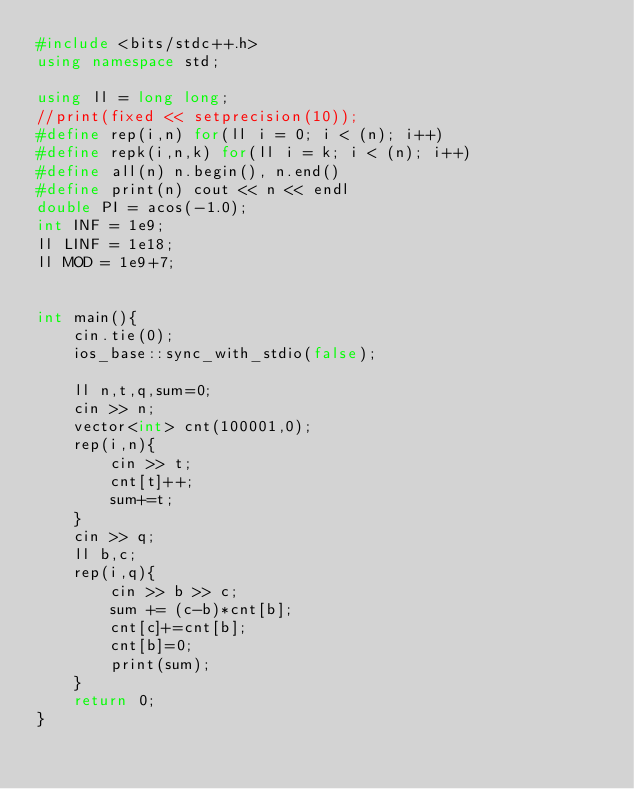Convert code to text. <code><loc_0><loc_0><loc_500><loc_500><_C++_>#include <bits/stdc++.h>
using namespace std;

using ll = long long;
//print(fixed << setprecision(10));
#define rep(i,n) for(ll i = 0; i < (n); i++)
#define repk(i,n,k) for(ll i = k; i < (n); i++)
#define all(n) n.begin(), n.end()
#define print(n) cout << n << endl
double PI = acos(-1.0);
int INF = 1e9;
ll LINF = 1e18;
ll MOD = 1e9+7;


int main(){
    cin.tie(0);
    ios_base::sync_with_stdio(false);
    
    ll n,t,q,sum=0;
    cin >> n;
    vector<int> cnt(100001,0);
    rep(i,n){
        cin >> t;
        cnt[t]++;
        sum+=t;
    }
    cin >> q;
    ll b,c;
    rep(i,q){
        cin >> b >> c;
        sum += (c-b)*cnt[b];
        cnt[c]+=cnt[b];
        cnt[b]=0;
        print(sum);
    }
    return 0;
}</code> 